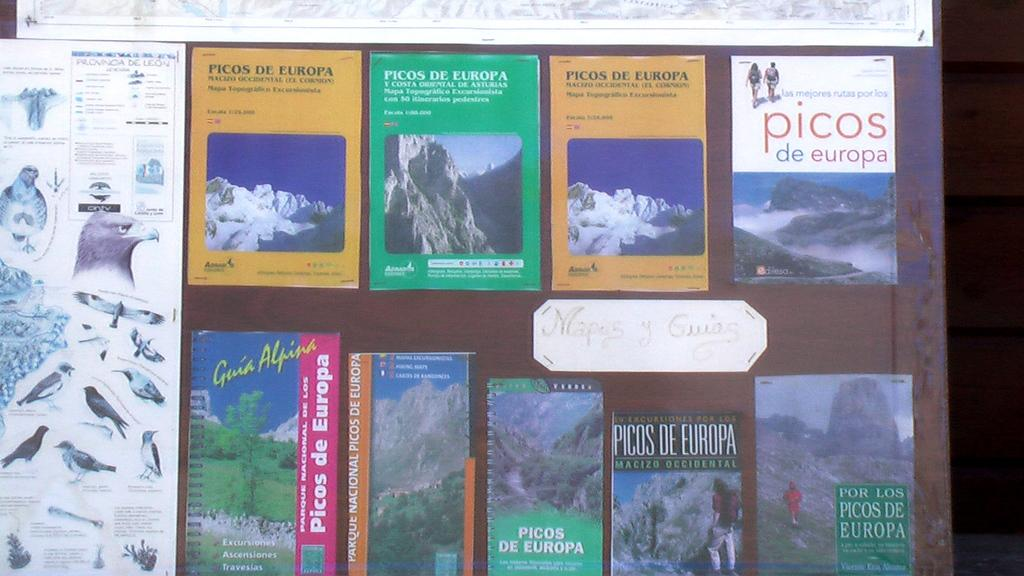<image>
Render a clear and concise summary of the photo. A bunch of books about the Picos De Europa national park. 